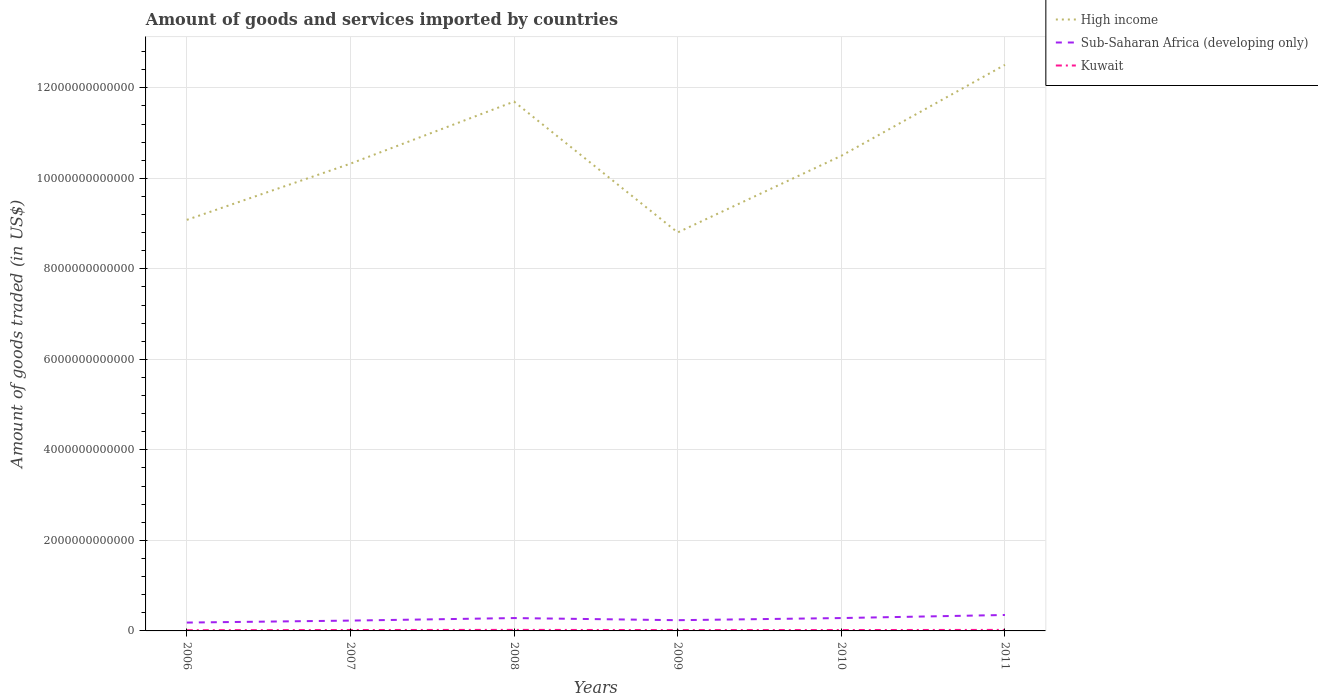How many different coloured lines are there?
Keep it short and to the point. 3. Is the number of lines equal to the number of legend labels?
Your answer should be very brief. Yes. Across all years, what is the maximum total amount of goods and services imported in Sub-Saharan Africa (developing only)?
Give a very brief answer. 1.85e+11. What is the total total amount of goods and services imported in Sub-Saharan Africa (developing only) in the graph?
Provide a succinct answer. -6.77e+1. What is the difference between the highest and the second highest total amount of goods and services imported in Kuwait?
Provide a succinct answer. 6.70e+09. What is the difference between two consecutive major ticks on the Y-axis?
Make the answer very short. 2.00e+12. Does the graph contain grids?
Offer a very short reply. Yes. Where does the legend appear in the graph?
Your answer should be compact. Top right. How many legend labels are there?
Offer a very short reply. 3. What is the title of the graph?
Offer a very short reply. Amount of goods and services imported by countries. What is the label or title of the X-axis?
Your answer should be compact. Years. What is the label or title of the Y-axis?
Give a very brief answer. Amount of goods traded (in US$). What is the Amount of goods traded (in US$) of High income in 2006?
Offer a very short reply. 9.08e+12. What is the Amount of goods traded (in US$) in Sub-Saharan Africa (developing only) in 2006?
Provide a succinct answer. 1.85e+11. What is the Amount of goods traded (in US$) in Kuwait in 2006?
Your answer should be compact. 1.62e+1. What is the Amount of goods traded (in US$) of High income in 2007?
Ensure brevity in your answer.  1.03e+13. What is the Amount of goods traded (in US$) of Sub-Saharan Africa (developing only) in 2007?
Keep it short and to the point. 2.28e+11. What is the Amount of goods traded (in US$) in Kuwait in 2007?
Give a very brief answer. 2.00e+1. What is the Amount of goods traded (in US$) in High income in 2008?
Your answer should be compact. 1.17e+13. What is the Amount of goods traded (in US$) in Sub-Saharan Africa (developing only) in 2008?
Your answer should be very brief. 2.84e+11. What is the Amount of goods traded (in US$) in Kuwait in 2008?
Offer a very short reply. 2.29e+1. What is the Amount of goods traded (in US$) of High income in 2009?
Your answer should be very brief. 8.80e+12. What is the Amount of goods traded (in US$) of Sub-Saharan Africa (developing only) in 2009?
Make the answer very short. 2.37e+11. What is the Amount of goods traded (in US$) in Kuwait in 2009?
Your response must be concise. 1.85e+1. What is the Amount of goods traded (in US$) of High income in 2010?
Your answer should be compact. 1.05e+13. What is the Amount of goods traded (in US$) of Sub-Saharan Africa (developing only) in 2010?
Ensure brevity in your answer.  2.84e+11. What is the Amount of goods traded (in US$) of Kuwait in 2010?
Ensure brevity in your answer.  1.96e+1. What is the Amount of goods traded (in US$) of High income in 2011?
Offer a very short reply. 1.25e+13. What is the Amount of goods traded (in US$) of Sub-Saharan Africa (developing only) in 2011?
Provide a short and direct response. 3.52e+11. What is the Amount of goods traded (in US$) of Kuwait in 2011?
Make the answer very short. 2.26e+1. Across all years, what is the maximum Amount of goods traded (in US$) in High income?
Provide a succinct answer. 1.25e+13. Across all years, what is the maximum Amount of goods traded (in US$) in Sub-Saharan Africa (developing only)?
Offer a terse response. 3.52e+11. Across all years, what is the maximum Amount of goods traded (in US$) of Kuwait?
Give a very brief answer. 2.29e+1. Across all years, what is the minimum Amount of goods traded (in US$) of High income?
Keep it short and to the point. 8.80e+12. Across all years, what is the minimum Amount of goods traded (in US$) in Sub-Saharan Africa (developing only)?
Make the answer very short. 1.85e+11. Across all years, what is the minimum Amount of goods traded (in US$) in Kuwait?
Make the answer very short. 1.62e+1. What is the total Amount of goods traded (in US$) of High income in the graph?
Offer a terse response. 6.29e+13. What is the total Amount of goods traded (in US$) in Sub-Saharan Africa (developing only) in the graph?
Provide a short and direct response. 1.57e+12. What is the total Amount of goods traded (in US$) of Kuwait in the graph?
Your answer should be compact. 1.20e+11. What is the difference between the Amount of goods traded (in US$) in High income in 2006 and that in 2007?
Your response must be concise. -1.24e+12. What is the difference between the Amount of goods traded (in US$) in Sub-Saharan Africa (developing only) in 2006 and that in 2007?
Offer a terse response. -4.36e+1. What is the difference between the Amount of goods traded (in US$) of Kuwait in 2006 and that in 2007?
Provide a short and direct response. -3.72e+09. What is the difference between the Amount of goods traded (in US$) in High income in 2006 and that in 2008?
Give a very brief answer. -2.61e+12. What is the difference between the Amount of goods traded (in US$) in Sub-Saharan Africa (developing only) in 2006 and that in 2008?
Your answer should be compact. -9.94e+1. What is the difference between the Amount of goods traded (in US$) of Kuwait in 2006 and that in 2008?
Ensure brevity in your answer.  -6.70e+09. What is the difference between the Amount of goods traded (in US$) in High income in 2006 and that in 2009?
Your answer should be compact. 2.78e+11. What is the difference between the Amount of goods traded (in US$) in Sub-Saharan Africa (developing only) in 2006 and that in 2009?
Ensure brevity in your answer.  -5.27e+1. What is the difference between the Amount of goods traded (in US$) in Kuwait in 2006 and that in 2009?
Give a very brief answer. -2.29e+09. What is the difference between the Amount of goods traded (in US$) in High income in 2006 and that in 2010?
Your answer should be very brief. -1.42e+12. What is the difference between the Amount of goods traded (in US$) of Sub-Saharan Africa (developing only) in 2006 and that in 2010?
Make the answer very short. -9.99e+1. What is the difference between the Amount of goods traded (in US$) in Kuwait in 2006 and that in 2010?
Keep it short and to the point. -3.33e+09. What is the difference between the Amount of goods traded (in US$) in High income in 2006 and that in 2011?
Provide a short and direct response. -3.43e+12. What is the difference between the Amount of goods traded (in US$) in Sub-Saharan Africa (developing only) in 2006 and that in 2011?
Give a very brief answer. -1.68e+11. What is the difference between the Amount of goods traded (in US$) of Kuwait in 2006 and that in 2011?
Provide a succinct answer. -6.36e+09. What is the difference between the Amount of goods traded (in US$) in High income in 2007 and that in 2008?
Keep it short and to the point. -1.37e+12. What is the difference between the Amount of goods traded (in US$) of Sub-Saharan Africa (developing only) in 2007 and that in 2008?
Give a very brief answer. -5.58e+1. What is the difference between the Amount of goods traded (in US$) in Kuwait in 2007 and that in 2008?
Your answer should be compact. -2.98e+09. What is the difference between the Amount of goods traded (in US$) of High income in 2007 and that in 2009?
Your answer should be compact. 1.52e+12. What is the difference between the Amount of goods traded (in US$) in Sub-Saharan Africa (developing only) in 2007 and that in 2009?
Your response must be concise. -9.09e+09. What is the difference between the Amount of goods traded (in US$) in Kuwait in 2007 and that in 2009?
Provide a short and direct response. 1.43e+09. What is the difference between the Amount of goods traded (in US$) in High income in 2007 and that in 2010?
Keep it short and to the point. -1.74e+11. What is the difference between the Amount of goods traded (in US$) of Sub-Saharan Africa (developing only) in 2007 and that in 2010?
Offer a very short reply. -5.63e+1. What is the difference between the Amount of goods traded (in US$) in Kuwait in 2007 and that in 2010?
Your response must be concise. 3.93e+08. What is the difference between the Amount of goods traded (in US$) in High income in 2007 and that in 2011?
Your response must be concise. -2.18e+12. What is the difference between the Amount of goods traded (in US$) of Sub-Saharan Africa (developing only) in 2007 and that in 2011?
Your answer should be very brief. -1.24e+11. What is the difference between the Amount of goods traded (in US$) in Kuwait in 2007 and that in 2011?
Provide a succinct answer. -2.64e+09. What is the difference between the Amount of goods traded (in US$) of High income in 2008 and that in 2009?
Offer a terse response. 2.89e+12. What is the difference between the Amount of goods traded (in US$) of Sub-Saharan Africa (developing only) in 2008 and that in 2009?
Give a very brief answer. 4.67e+1. What is the difference between the Amount of goods traded (in US$) of Kuwait in 2008 and that in 2009?
Provide a succinct answer. 4.41e+09. What is the difference between the Amount of goods traded (in US$) of High income in 2008 and that in 2010?
Provide a short and direct response. 1.20e+12. What is the difference between the Amount of goods traded (in US$) of Sub-Saharan Africa (developing only) in 2008 and that in 2010?
Give a very brief answer. -4.86e+08. What is the difference between the Amount of goods traded (in US$) in Kuwait in 2008 and that in 2010?
Provide a succinct answer. 3.37e+09. What is the difference between the Amount of goods traded (in US$) of High income in 2008 and that in 2011?
Keep it short and to the point. -8.12e+11. What is the difference between the Amount of goods traded (in US$) in Sub-Saharan Africa (developing only) in 2008 and that in 2011?
Give a very brief answer. -6.82e+1. What is the difference between the Amount of goods traded (in US$) of Kuwait in 2008 and that in 2011?
Your answer should be very brief. 3.42e+08. What is the difference between the Amount of goods traded (in US$) of High income in 2009 and that in 2010?
Give a very brief answer. -1.69e+12. What is the difference between the Amount of goods traded (in US$) of Sub-Saharan Africa (developing only) in 2009 and that in 2010?
Make the answer very short. -4.72e+1. What is the difference between the Amount of goods traded (in US$) in Kuwait in 2009 and that in 2010?
Offer a terse response. -1.04e+09. What is the difference between the Amount of goods traded (in US$) in High income in 2009 and that in 2011?
Your answer should be very brief. -3.70e+12. What is the difference between the Amount of goods traded (in US$) of Sub-Saharan Africa (developing only) in 2009 and that in 2011?
Your answer should be very brief. -1.15e+11. What is the difference between the Amount of goods traded (in US$) of Kuwait in 2009 and that in 2011?
Your response must be concise. -4.07e+09. What is the difference between the Amount of goods traded (in US$) in High income in 2010 and that in 2011?
Provide a short and direct response. -2.01e+12. What is the difference between the Amount of goods traded (in US$) of Sub-Saharan Africa (developing only) in 2010 and that in 2011?
Make the answer very short. -6.77e+1. What is the difference between the Amount of goods traded (in US$) of Kuwait in 2010 and that in 2011?
Offer a terse response. -3.03e+09. What is the difference between the Amount of goods traded (in US$) in High income in 2006 and the Amount of goods traded (in US$) in Sub-Saharan Africa (developing only) in 2007?
Your answer should be very brief. 8.85e+12. What is the difference between the Amount of goods traded (in US$) of High income in 2006 and the Amount of goods traded (in US$) of Kuwait in 2007?
Give a very brief answer. 9.06e+12. What is the difference between the Amount of goods traded (in US$) of Sub-Saharan Africa (developing only) in 2006 and the Amount of goods traded (in US$) of Kuwait in 2007?
Your answer should be very brief. 1.65e+11. What is the difference between the Amount of goods traded (in US$) of High income in 2006 and the Amount of goods traded (in US$) of Sub-Saharan Africa (developing only) in 2008?
Your response must be concise. 8.80e+12. What is the difference between the Amount of goods traded (in US$) of High income in 2006 and the Amount of goods traded (in US$) of Kuwait in 2008?
Offer a terse response. 9.06e+12. What is the difference between the Amount of goods traded (in US$) of Sub-Saharan Africa (developing only) in 2006 and the Amount of goods traded (in US$) of Kuwait in 2008?
Offer a terse response. 1.62e+11. What is the difference between the Amount of goods traded (in US$) in High income in 2006 and the Amount of goods traded (in US$) in Sub-Saharan Africa (developing only) in 2009?
Your response must be concise. 8.85e+12. What is the difference between the Amount of goods traded (in US$) of High income in 2006 and the Amount of goods traded (in US$) of Kuwait in 2009?
Ensure brevity in your answer.  9.06e+12. What is the difference between the Amount of goods traded (in US$) in Sub-Saharan Africa (developing only) in 2006 and the Amount of goods traded (in US$) in Kuwait in 2009?
Offer a terse response. 1.66e+11. What is the difference between the Amount of goods traded (in US$) of High income in 2006 and the Amount of goods traded (in US$) of Sub-Saharan Africa (developing only) in 2010?
Make the answer very short. 8.80e+12. What is the difference between the Amount of goods traded (in US$) in High income in 2006 and the Amount of goods traded (in US$) in Kuwait in 2010?
Offer a very short reply. 9.06e+12. What is the difference between the Amount of goods traded (in US$) in Sub-Saharan Africa (developing only) in 2006 and the Amount of goods traded (in US$) in Kuwait in 2010?
Offer a terse response. 1.65e+11. What is the difference between the Amount of goods traded (in US$) of High income in 2006 and the Amount of goods traded (in US$) of Sub-Saharan Africa (developing only) in 2011?
Offer a terse response. 8.73e+12. What is the difference between the Amount of goods traded (in US$) in High income in 2006 and the Amount of goods traded (in US$) in Kuwait in 2011?
Ensure brevity in your answer.  9.06e+12. What is the difference between the Amount of goods traded (in US$) of Sub-Saharan Africa (developing only) in 2006 and the Amount of goods traded (in US$) of Kuwait in 2011?
Your answer should be very brief. 1.62e+11. What is the difference between the Amount of goods traded (in US$) of High income in 2007 and the Amount of goods traded (in US$) of Sub-Saharan Africa (developing only) in 2008?
Your response must be concise. 1.00e+13. What is the difference between the Amount of goods traded (in US$) of High income in 2007 and the Amount of goods traded (in US$) of Kuwait in 2008?
Your answer should be very brief. 1.03e+13. What is the difference between the Amount of goods traded (in US$) in Sub-Saharan Africa (developing only) in 2007 and the Amount of goods traded (in US$) in Kuwait in 2008?
Ensure brevity in your answer.  2.05e+11. What is the difference between the Amount of goods traded (in US$) of High income in 2007 and the Amount of goods traded (in US$) of Sub-Saharan Africa (developing only) in 2009?
Ensure brevity in your answer.  1.01e+13. What is the difference between the Amount of goods traded (in US$) of High income in 2007 and the Amount of goods traded (in US$) of Kuwait in 2009?
Make the answer very short. 1.03e+13. What is the difference between the Amount of goods traded (in US$) of Sub-Saharan Africa (developing only) in 2007 and the Amount of goods traded (in US$) of Kuwait in 2009?
Make the answer very short. 2.10e+11. What is the difference between the Amount of goods traded (in US$) in High income in 2007 and the Amount of goods traded (in US$) in Sub-Saharan Africa (developing only) in 2010?
Keep it short and to the point. 1.00e+13. What is the difference between the Amount of goods traded (in US$) of High income in 2007 and the Amount of goods traded (in US$) of Kuwait in 2010?
Offer a very short reply. 1.03e+13. What is the difference between the Amount of goods traded (in US$) of Sub-Saharan Africa (developing only) in 2007 and the Amount of goods traded (in US$) of Kuwait in 2010?
Offer a terse response. 2.09e+11. What is the difference between the Amount of goods traded (in US$) of High income in 2007 and the Amount of goods traded (in US$) of Sub-Saharan Africa (developing only) in 2011?
Keep it short and to the point. 9.97e+12. What is the difference between the Amount of goods traded (in US$) of High income in 2007 and the Amount of goods traded (in US$) of Kuwait in 2011?
Keep it short and to the point. 1.03e+13. What is the difference between the Amount of goods traded (in US$) of Sub-Saharan Africa (developing only) in 2007 and the Amount of goods traded (in US$) of Kuwait in 2011?
Give a very brief answer. 2.06e+11. What is the difference between the Amount of goods traded (in US$) of High income in 2008 and the Amount of goods traded (in US$) of Sub-Saharan Africa (developing only) in 2009?
Ensure brevity in your answer.  1.15e+13. What is the difference between the Amount of goods traded (in US$) in High income in 2008 and the Amount of goods traded (in US$) in Kuwait in 2009?
Offer a very short reply. 1.17e+13. What is the difference between the Amount of goods traded (in US$) of Sub-Saharan Africa (developing only) in 2008 and the Amount of goods traded (in US$) of Kuwait in 2009?
Keep it short and to the point. 2.65e+11. What is the difference between the Amount of goods traded (in US$) of High income in 2008 and the Amount of goods traded (in US$) of Sub-Saharan Africa (developing only) in 2010?
Make the answer very short. 1.14e+13. What is the difference between the Amount of goods traded (in US$) of High income in 2008 and the Amount of goods traded (in US$) of Kuwait in 2010?
Offer a terse response. 1.17e+13. What is the difference between the Amount of goods traded (in US$) of Sub-Saharan Africa (developing only) in 2008 and the Amount of goods traded (in US$) of Kuwait in 2010?
Offer a terse response. 2.64e+11. What is the difference between the Amount of goods traded (in US$) of High income in 2008 and the Amount of goods traded (in US$) of Sub-Saharan Africa (developing only) in 2011?
Give a very brief answer. 1.13e+13. What is the difference between the Amount of goods traded (in US$) in High income in 2008 and the Amount of goods traded (in US$) in Kuwait in 2011?
Keep it short and to the point. 1.17e+13. What is the difference between the Amount of goods traded (in US$) in Sub-Saharan Africa (developing only) in 2008 and the Amount of goods traded (in US$) in Kuwait in 2011?
Give a very brief answer. 2.61e+11. What is the difference between the Amount of goods traded (in US$) in High income in 2009 and the Amount of goods traded (in US$) in Sub-Saharan Africa (developing only) in 2010?
Offer a very short reply. 8.52e+12. What is the difference between the Amount of goods traded (in US$) in High income in 2009 and the Amount of goods traded (in US$) in Kuwait in 2010?
Offer a very short reply. 8.78e+12. What is the difference between the Amount of goods traded (in US$) in Sub-Saharan Africa (developing only) in 2009 and the Amount of goods traded (in US$) in Kuwait in 2010?
Your answer should be very brief. 2.18e+11. What is the difference between the Amount of goods traded (in US$) in High income in 2009 and the Amount of goods traded (in US$) in Sub-Saharan Africa (developing only) in 2011?
Offer a terse response. 8.45e+12. What is the difference between the Amount of goods traded (in US$) in High income in 2009 and the Amount of goods traded (in US$) in Kuwait in 2011?
Offer a terse response. 8.78e+12. What is the difference between the Amount of goods traded (in US$) in Sub-Saharan Africa (developing only) in 2009 and the Amount of goods traded (in US$) in Kuwait in 2011?
Offer a very short reply. 2.15e+11. What is the difference between the Amount of goods traded (in US$) in High income in 2010 and the Amount of goods traded (in US$) in Sub-Saharan Africa (developing only) in 2011?
Make the answer very short. 1.01e+13. What is the difference between the Amount of goods traded (in US$) of High income in 2010 and the Amount of goods traded (in US$) of Kuwait in 2011?
Provide a short and direct response. 1.05e+13. What is the difference between the Amount of goods traded (in US$) of Sub-Saharan Africa (developing only) in 2010 and the Amount of goods traded (in US$) of Kuwait in 2011?
Your answer should be compact. 2.62e+11. What is the average Amount of goods traded (in US$) of High income per year?
Make the answer very short. 1.05e+13. What is the average Amount of goods traded (in US$) of Sub-Saharan Africa (developing only) per year?
Offer a very short reply. 2.62e+11. What is the average Amount of goods traded (in US$) of Kuwait per year?
Your answer should be compact. 2.00e+1. In the year 2006, what is the difference between the Amount of goods traded (in US$) of High income and Amount of goods traded (in US$) of Sub-Saharan Africa (developing only)?
Make the answer very short. 8.90e+12. In the year 2006, what is the difference between the Amount of goods traded (in US$) of High income and Amount of goods traded (in US$) of Kuwait?
Provide a short and direct response. 9.07e+12. In the year 2006, what is the difference between the Amount of goods traded (in US$) in Sub-Saharan Africa (developing only) and Amount of goods traded (in US$) in Kuwait?
Keep it short and to the point. 1.68e+11. In the year 2007, what is the difference between the Amount of goods traded (in US$) in High income and Amount of goods traded (in US$) in Sub-Saharan Africa (developing only)?
Your answer should be very brief. 1.01e+13. In the year 2007, what is the difference between the Amount of goods traded (in US$) in High income and Amount of goods traded (in US$) in Kuwait?
Ensure brevity in your answer.  1.03e+13. In the year 2007, what is the difference between the Amount of goods traded (in US$) of Sub-Saharan Africa (developing only) and Amount of goods traded (in US$) of Kuwait?
Ensure brevity in your answer.  2.08e+11. In the year 2008, what is the difference between the Amount of goods traded (in US$) of High income and Amount of goods traded (in US$) of Sub-Saharan Africa (developing only)?
Make the answer very short. 1.14e+13. In the year 2008, what is the difference between the Amount of goods traded (in US$) of High income and Amount of goods traded (in US$) of Kuwait?
Ensure brevity in your answer.  1.17e+13. In the year 2008, what is the difference between the Amount of goods traded (in US$) in Sub-Saharan Africa (developing only) and Amount of goods traded (in US$) in Kuwait?
Your response must be concise. 2.61e+11. In the year 2009, what is the difference between the Amount of goods traded (in US$) of High income and Amount of goods traded (in US$) of Sub-Saharan Africa (developing only)?
Your answer should be compact. 8.57e+12. In the year 2009, what is the difference between the Amount of goods traded (in US$) in High income and Amount of goods traded (in US$) in Kuwait?
Ensure brevity in your answer.  8.79e+12. In the year 2009, what is the difference between the Amount of goods traded (in US$) in Sub-Saharan Africa (developing only) and Amount of goods traded (in US$) in Kuwait?
Provide a succinct answer. 2.19e+11. In the year 2010, what is the difference between the Amount of goods traded (in US$) in High income and Amount of goods traded (in US$) in Sub-Saharan Africa (developing only)?
Your response must be concise. 1.02e+13. In the year 2010, what is the difference between the Amount of goods traded (in US$) in High income and Amount of goods traded (in US$) in Kuwait?
Keep it short and to the point. 1.05e+13. In the year 2010, what is the difference between the Amount of goods traded (in US$) in Sub-Saharan Africa (developing only) and Amount of goods traded (in US$) in Kuwait?
Provide a short and direct response. 2.65e+11. In the year 2011, what is the difference between the Amount of goods traded (in US$) of High income and Amount of goods traded (in US$) of Sub-Saharan Africa (developing only)?
Your answer should be compact. 1.22e+13. In the year 2011, what is the difference between the Amount of goods traded (in US$) of High income and Amount of goods traded (in US$) of Kuwait?
Offer a terse response. 1.25e+13. In the year 2011, what is the difference between the Amount of goods traded (in US$) in Sub-Saharan Africa (developing only) and Amount of goods traded (in US$) in Kuwait?
Provide a short and direct response. 3.30e+11. What is the ratio of the Amount of goods traded (in US$) in High income in 2006 to that in 2007?
Your answer should be very brief. 0.88. What is the ratio of the Amount of goods traded (in US$) of Sub-Saharan Africa (developing only) in 2006 to that in 2007?
Your answer should be very brief. 0.81. What is the ratio of the Amount of goods traded (in US$) in Kuwait in 2006 to that in 2007?
Your answer should be compact. 0.81. What is the ratio of the Amount of goods traded (in US$) in High income in 2006 to that in 2008?
Provide a short and direct response. 0.78. What is the ratio of the Amount of goods traded (in US$) in Sub-Saharan Africa (developing only) in 2006 to that in 2008?
Ensure brevity in your answer.  0.65. What is the ratio of the Amount of goods traded (in US$) of Kuwait in 2006 to that in 2008?
Offer a very short reply. 0.71. What is the ratio of the Amount of goods traded (in US$) of High income in 2006 to that in 2009?
Your answer should be compact. 1.03. What is the ratio of the Amount of goods traded (in US$) of Sub-Saharan Africa (developing only) in 2006 to that in 2009?
Keep it short and to the point. 0.78. What is the ratio of the Amount of goods traded (in US$) in Kuwait in 2006 to that in 2009?
Your answer should be very brief. 0.88. What is the ratio of the Amount of goods traded (in US$) of High income in 2006 to that in 2010?
Make the answer very short. 0.87. What is the ratio of the Amount of goods traded (in US$) in Sub-Saharan Africa (developing only) in 2006 to that in 2010?
Keep it short and to the point. 0.65. What is the ratio of the Amount of goods traded (in US$) of Kuwait in 2006 to that in 2010?
Provide a succinct answer. 0.83. What is the ratio of the Amount of goods traded (in US$) in High income in 2006 to that in 2011?
Provide a succinct answer. 0.73. What is the ratio of the Amount of goods traded (in US$) in Sub-Saharan Africa (developing only) in 2006 to that in 2011?
Provide a succinct answer. 0.52. What is the ratio of the Amount of goods traded (in US$) of Kuwait in 2006 to that in 2011?
Your response must be concise. 0.72. What is the ratio of the Amount of goods traded (in US$) in High income in 2007 to that in 2008?
Your answer should be compact. 0.88. What is the ratio of the Amount of goods traded (in US$) of Sub-Saharan Africa (developing only) in 2007 to that in 2008?
Keep it short and to the point. 0.8. What is the ratio of the Amount of goods traded (in US$) in Kuwait in 2007 to that in 2008?
Keep it short and to the point. 0.87. What is the ratio of the Amount of goods traded (in US$) in High income in 2007 to that in 2009?
Your answer should be very brief. 1.17. What is the ratio of the Amount of goods traded (in US$) of Sub-Saharan Africa (developing only) in 2007 to that in 2009?
Give a very brief answer. 0.96. What is the ratio of the Amount of goods traded (in US$) of Kuwait in 2007 to that in 2009?
Offer a terse response. 1.08. What is the ratio of the Amount of goods traded (in US$) in High income in 2007 to that in 2010?
Your answer should be compact. 0.98. What is the ratio of the Amount of goods traded (in US$) of Sub-Saharan Africa (developing only) in 2007 to that in 2010?
Provide a short and direct response. 0.8. What is the ratio of the Amount of goods traded (in US$) in Kuwait in 2007 to that in 2010?
Ensure brevity in your answer.  1.02. What is the ratio of the Amount of goods traded (in US$) in High income in 2007 to that in 2011?
Give a very brief answer. 0.83. What is the ratio of the Amount of goods traded (in US$) in Sub-Saharan Africa (developing only) in 2007 to that in 2011?
Your response must be concise. 0.65. What is the ratio of the Amount of goods traded (in US$) in Kuwait in 2007 to that in 2011?
Your answer should be very brief. 0.88. What is the ratio of the Amount of goods traded (in US$) of High income in 2008 to that in 2009?
Make the answer very short. 1.33. What is the ratio of the Amount of goods traded (in US$) in Sub-Saharan Africa (developing only) in 2008 to that in 2009?
Ensure brevity in your answer.  1.2. What is the ratio of the Amount of goods traded (in US$) in Kuwait in 2008 to that in 2009?
Offer a very short reply. 1.24. What is the ratio of the Amount of goods traded (in US$) of High income in 2008 to that in 2010?
Offer a very short reply. 1.11. What is the ratio of the Amount of goods traded (in US$) of Sub-Saharan Africa (developing only) in 2008 to that in 2010?
Provide a short and direct response. 1. What is the ratio of the Amount of goods traded (in US$) in Kuwait in 2008 to that in 2010?
Give a very brief answer. 1.17. What is the ratio of the Amount of goods traded (in US$) of High income in 2008 to that in 2011?
Give a very brief answer. 0.94. What is the ratio of the Amount of goods traded (in US$) in Sub-Saharan Africa (developing only) in 2008 to that in 2011?
Provide a succinct answer. 0.81. What is the ratio of the Amount of goods traded (in US$) of Kuwait in 2008 to that in 2011?
Provide a succinct answer. 1.02. What is the ratio of the Amount of goods traded (in US$) of High income in 2009 to that in 2010?
Ensure brevity in your answer.  0.84. What is the ratio of the Amount of goods traded (in US$) in Sub-Saharan Africa (developing only) in 2009 to that in 2010?
Offer a terse response. 0.83. What is the ratio of the Amount of goods traded (in US$) in Kuwait in 2009 to that in 2010?
Provide a short and direct response. 0.95. What is the ratio of the Amount of goods traded (in US$) in High income in 2009 to that in 2011?
Provide a short and direct response. 0.7. What is the ratio of the Amount of goods traded (in US$) of Sub-Saharan Africa (developing only) in 2009 to that in 2011?
Provide a short and direct response. 0.67. What is the ratio of the Amount of goods traded (in US$) in Kuwait in 2009 to that in 2011?
Your response must be concise. 0.82. What is the ratio of the Amount of goods traded (in US$) in High income in 2010 to that in 2011?
Make the answer very short. 0.84. What is the ratio of the Amount of goods traded (in US$) in Sub-Saharan Africa (developing only) in 2010 to that in 2011?
Offer a very short reply. 0.81. What is the ratio of the Amount of goods traded (in US$) of Kuwait in 2010 to that in 2011?
Offer a terse response. 0.87. What is the difference between the highest and the second highest Amount of goods traded (in US$) in High income?
Offer a very short reply. 8.12e+11. What is the difference between the highest and the second highest Amount of goods traded (in US$) of Sub-Saharan Africa (developing only)?
Your response must be concise. 6.77e+1. What is the difference between the highest and the second highest Amount of goods traded (in US$) in Kuwait?
Offer a terse response. 3.42e+08. What is the difference between the highest and the lowest Amount of goods traded (in US$) of High income?
Offer a terse response. 3.70e+12. What is the difference between the highest and the lowest Amount of goods traded (in US$) in Sub-Saharan Africa (developing only)?
Keep it short and to the point. 1.68e+11. What is the difference between the highest and the lowest Amount of goods traded (in US$) of Kuwait?
Provide a succinct answer. 6.70e+09. 